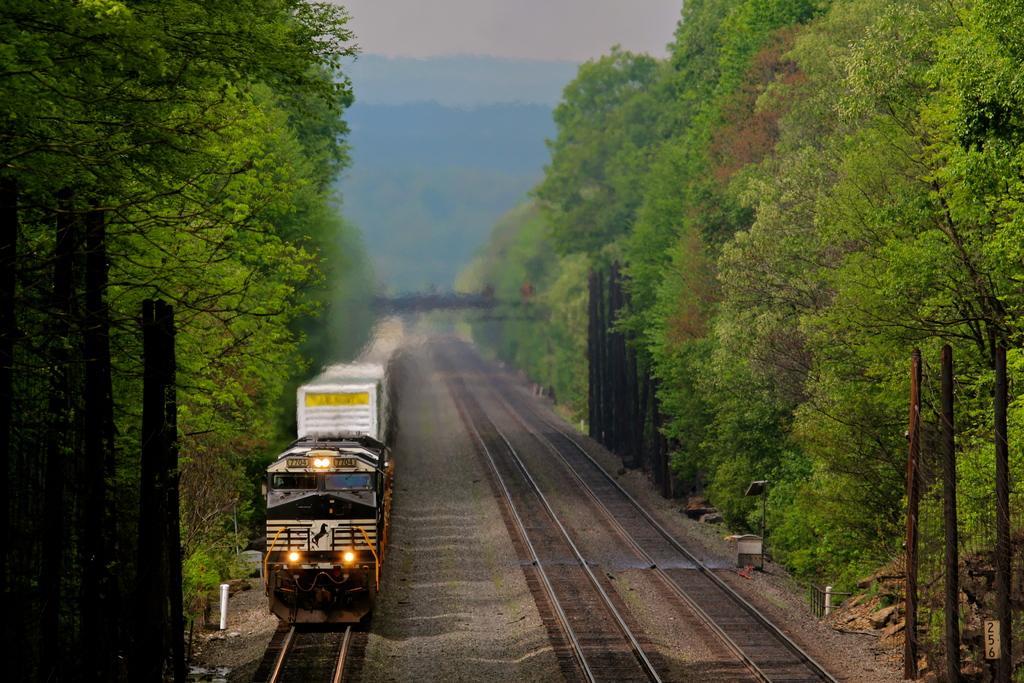Please provide a concise description of this image. On the left side of the image we can see a train on the tracks, beside to the train we can find few trees. 